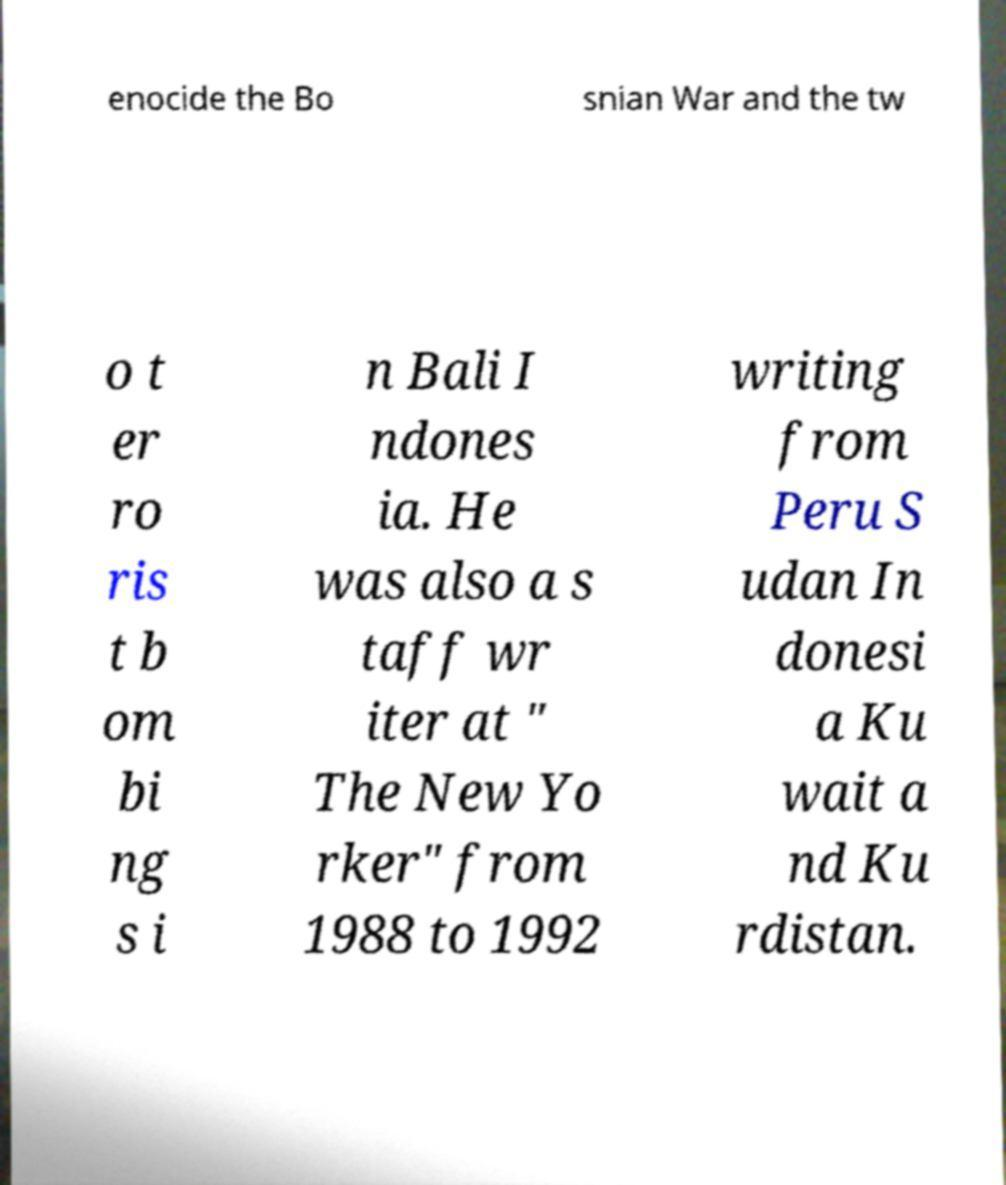Could you extract and type out the text from this image? enocide the Bo snian War and the tw o t er ro ris t b om bi ng s i n Bali I ndones ia. He was also a s taff wr iter at " The New Yo rker" from 1988 to 1992 writing from Peru S udan In donesi a Ku wait a nd Ku rdistan. 